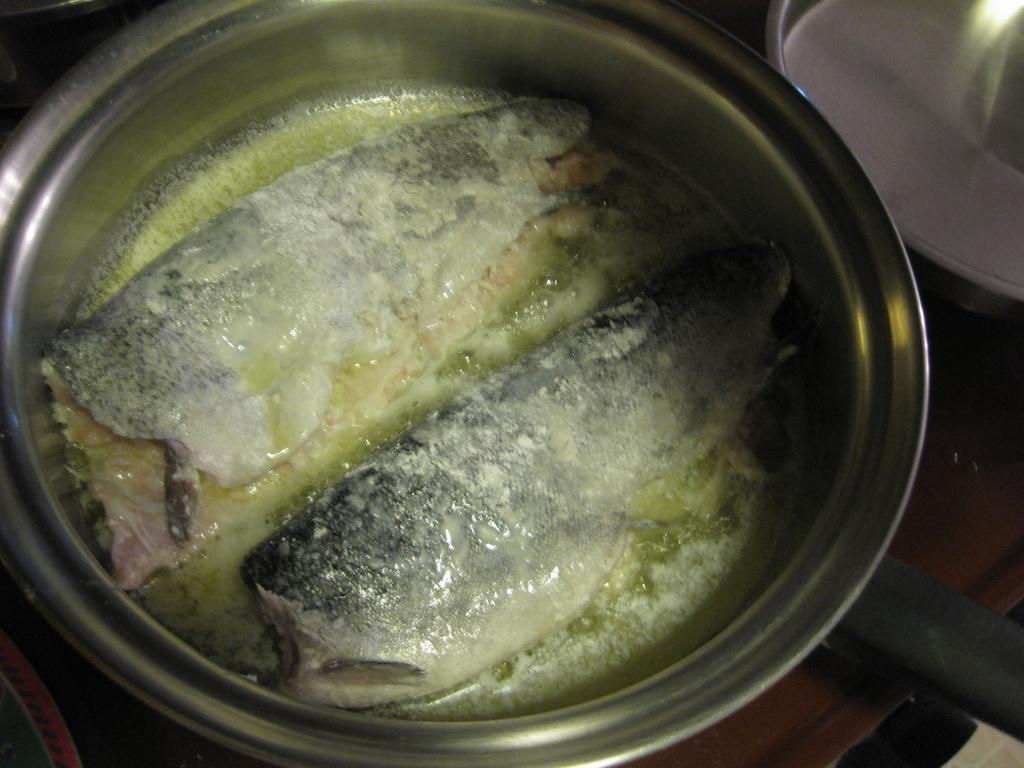What type of food is being prepared in the pan? There are fish pieces and soup in the pan. What can be seen on the right side of the image? There is a container on the right side of the image. How can the pan be handled while cooking? There is a pan handle visible in the image. What type of cakes can be seen being loaded onto the railway in the image? There are no cakes or railway present in the image. 